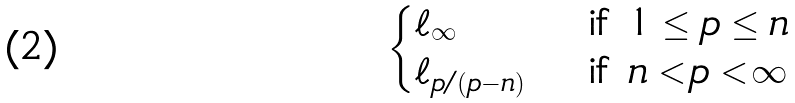Convert formula to latex. <formula><loc_0><loc_0><loc_500><loc_500>\begin{cases} \ell _ { \infty } & \text { if } 1 \leq p \leq n \\ \ell _ { p / ( p - n ) } & \text { if } n < p < \infty \end{cases}</formula> 